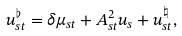Convert formula to latex. <formula><loc_0><loc_0><loc_500><loc_500>u ^ { \flat } _ { s t } = \delta \mu _ { s t } + A ^ { 2 } _ { s t } u _ { s } + u _ { s t } ^ { \natural } ,</formula> 